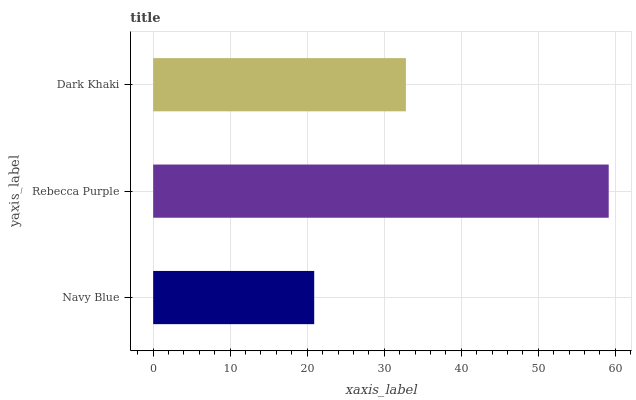Is Navy Blue the minimum?
Answer yes or no. Yes. Is Rebecca Purple the maximum?
Answer yes or no. Yes. Is Dark Khaki the minimum?
Answer yes or no. No. Is Dark Khaki the maximum?
Answer yes or no. No. Is Rebecca Purple greater than Dark Khaki?
Answer yes or no. Yes. Is Dark Khaki less than Rebecca Purple?
Answer yes or no. Yes. Is Dark Khaki greater than Rebecca Purple?
Answer yes or no. No. Is Rebecca Purple less than Dark Khaki?
Answer yes or no. No. Is Dark Khaki the high median?
Answer yes or no. Yes. Is Dark Khaki the low median?
Answer yes or no. Yes. Is Rebecca Purple the high median?
Answer yes or no. No. Is Navy Blue the low median?
Answer yes or no. No. 